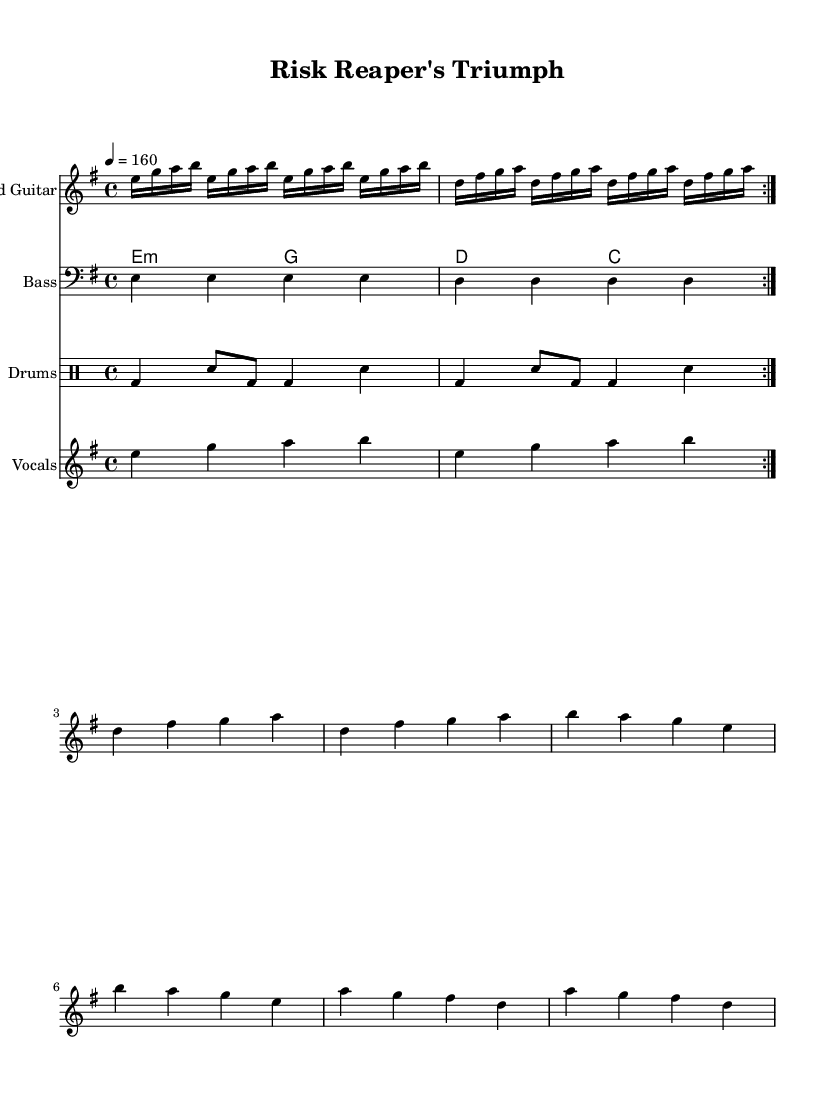What is the key signature of this music? The key signature is indicated at the beginning of the sheet music. The 'e minor' key signature consists of one sharp (F#).
Answer: E minor What is the time signature? The time signature is found right after the key signature at the beginning of the music. It reads 4/4, which means there are four beats in each measure.
Answer: 4/4 What is the tempo marking? The tempo marking is stated in beats per minute. It indicates the speed of the music, which is set at 160 beats per minute in this score.
Answer: 160 How many measures are in the verse section of the vocals? To find this, we identify the verse pattern within the vocals section and count the measures. The lyrics indicate four measures of verse.
Answer: Four What is the main theme of the lyrics? The lyrics focus on resilience in the face of crises, expressing a message of rising above challenges. This theme is inferred from phrases that mention markets crashing and rebirth.
Answer: Resilience What type of musical forms are used in the sheet music? The sheet music consists of a repetition ('volta') for the lead guitar, indicating a standard verse-chorus structure that is common in heavy metal anthems.
Answer: Verse-Chorus What instrument plays the lead melody? The lead melody is played by the staff labeled as "Lead Guitar," showing that the main melodic lines are in the part designated for the lead guitar.
Answer: Lead Guitar 